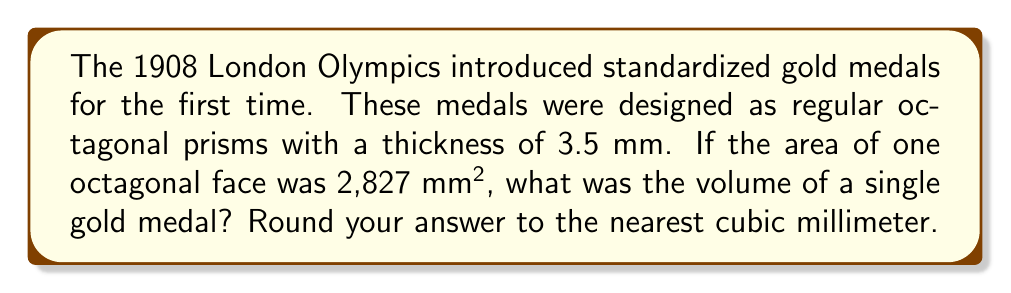Teach me how to tackle this problem. To solve this problem, we need to follow these steps:

1) First, we need to understand that the volume of a prism is given by the formula:

   $$V = A \cdot h$$

   where $V$ is the volume, $A$ is the area of the base, and $h$ is the height (thickness) of the prism.

2) We are given that:
   - The area of one octagonal face (A) = 2,827 mm²
   - The thickness of the medal (h) = 3.5 mm

3) Now, let's substitute these values into our volume formula:

   $$V = 2,827 \cdot 3.5$$

4) Calculating this:

   $$V = 9,894.5 \text{ mm}^3$$

5) Rounding to the nearest cubic millimeter:

   $$V \approx 9,895 \text{ mm}^3$$

This calculation gives us the volume of a single gold medal from the 1908 London Olympics, connecting the geometric properties of the medal to a significant moment in early 20th century international sports history.
Answer: 9,895 mm³ 